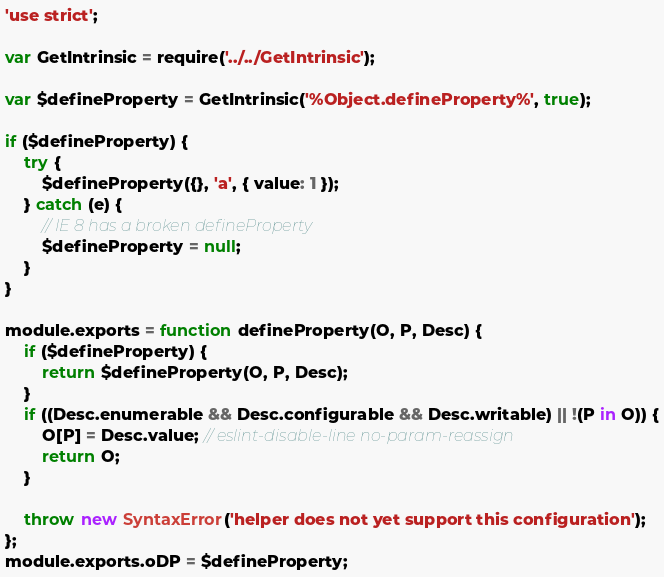Convert code to text. <code><loc_0><loc_0><loc_500><loc_500><_JavaScript_>'use strict';

var GetIntrinsic = require('../../GetIntrinsic');

var $defineProperty = GetIntrinsic('%Object.defineProperty%', true);

if ($defineProperty) {
	try {
		$defineProperty({}, 'a', { value: 1 });
	} catch (e) {
		// IE 8 has a broken defineProperty
		$defineProperty = null;
	}
}

module.exports = function defineProperty(O, P, Desc) {
	if ($defineProperty) {
		return $defineProperty(O, P, Desc);
	}
	if ((Desc.enumerable && Desc.configurable && Desc.writable) || !(P in O)) {
		O[P] = Desc.value; // eslint-disable-line no-param-reassign
		return O;
	}

	throw new SyntaxError('helper does not yet support this configuration');
};
module.exports.oDP = $defineProperty;
</code> 